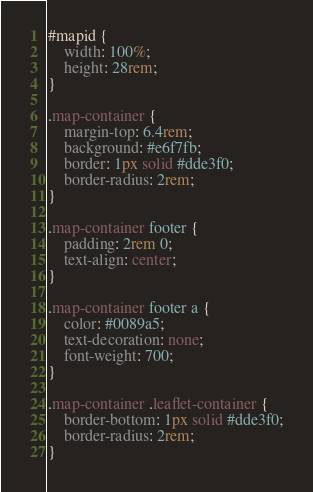<code> <loc_0><loc_0><loc_500><loc_500><_CSS_>#mapid {
    width: 100%;
    height: 28rem;    
}

.map-container {
    margin-top: 6.4rem;
    background: #e6f7fb;
    border: 1px solid #dde3f0;
    border-radius: 2rem;
}

.map-container footer {
    padding: 2rem 0;
    text-align: center;
}

.map-container footer a {
    color: #0089a5;
    text-decoration: none;
    font-weight: 700;
}

.map-container .leaflet-container {
    border-bottom: 1px solid #dde3f0;
    border-radius: 2rem;
}
</code> 